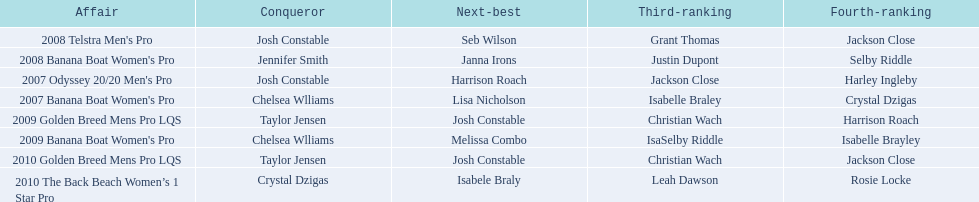What is the total number of times chelsea williams was the winner between 2007 and 2010? 2. 